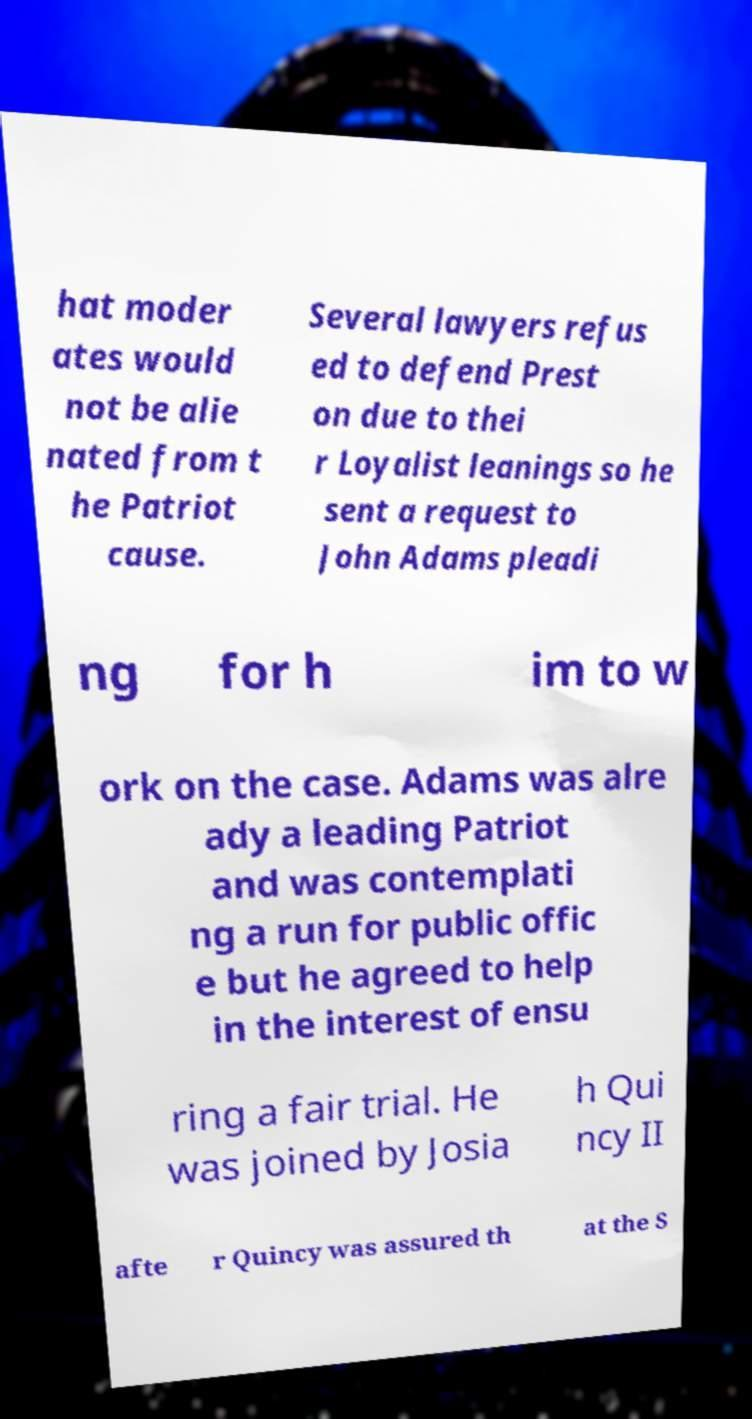There's text embedded in this image that I need extracted. Can you transcribe it verbatim? hat moder ates would not be alie nated from t he Patriot cause. Several lawyers refus ed to defend Prest on due to thei r Loyalist leanings so he sent a request to John Adams pleadi ng for h im to w ork on the case. Adams was alre ady a leading Patriot and was contemplati ng a run for public offic e but he agreed to help in the interest of ensu ring a fair trial. He was joined by Josia h Qui ncy II afte r Quincy was assured th at the S 